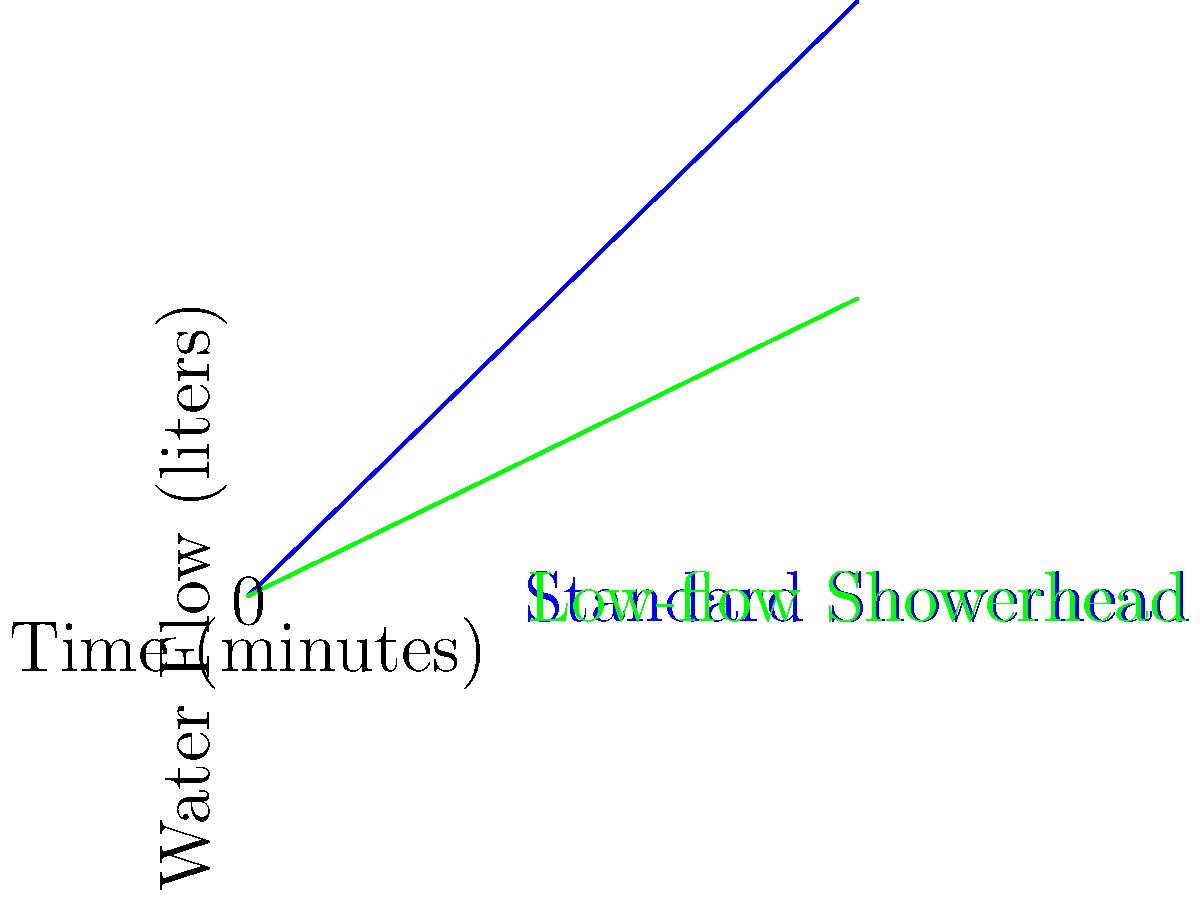A hotel is considering switching to low-flow showerheads to reduce water consumption. The graph shows water flow rates for standard and low-flow showerheads over time. If the average guest shower duration is 12 minutes, how many liters of water would be saved per shower by switching to the low-flow showerhead? To solve this problem, we need to follow these steps:

1. Determine the water flow rate for each showerhead:
   - Standard showerhead: $\frac{40 \text{ L}}{20 \text{ min}} = 2 \text{ L/min}$
   - Low-flow showerhead: $\frac{20 \text{ L}}{20 \text{ min}} = 1 \text{ L/min}$

2. Calculate the water used in 12 minutes for each showerhead:
   - Standard showerhead: $12 \text{ min} \times 2 \text{ L/min} = 24 \text{ L}$
   - Low-flow showerhead: $12 \text{ min} \times 1 \text{ L/min} = 12 \text{ L}$

3. Calculate the difference in water usage:
   $24 \text{ L} - 12 \text{ L} = 12 \text{ L}$

Therefore, switching to the low-flow showerhead would save 12 liters of water per shower.
Answer: 12 liters 